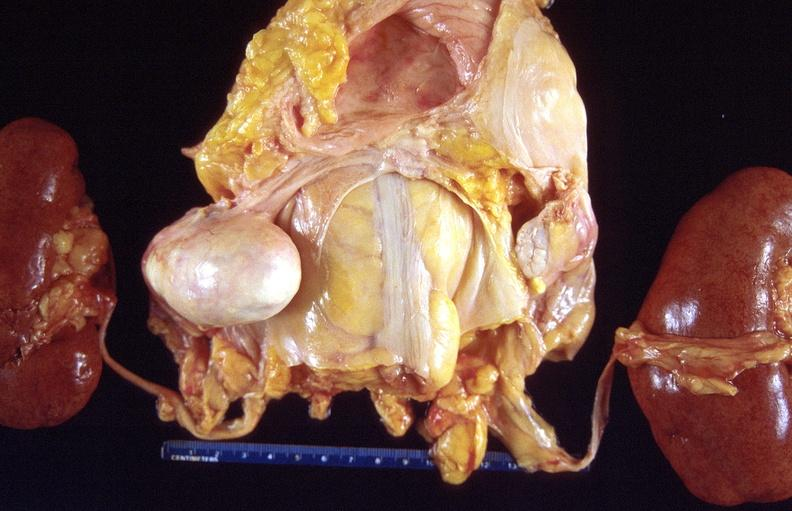what does this image show?
Answer the question using a single word or phrase. Dermoid cyst 